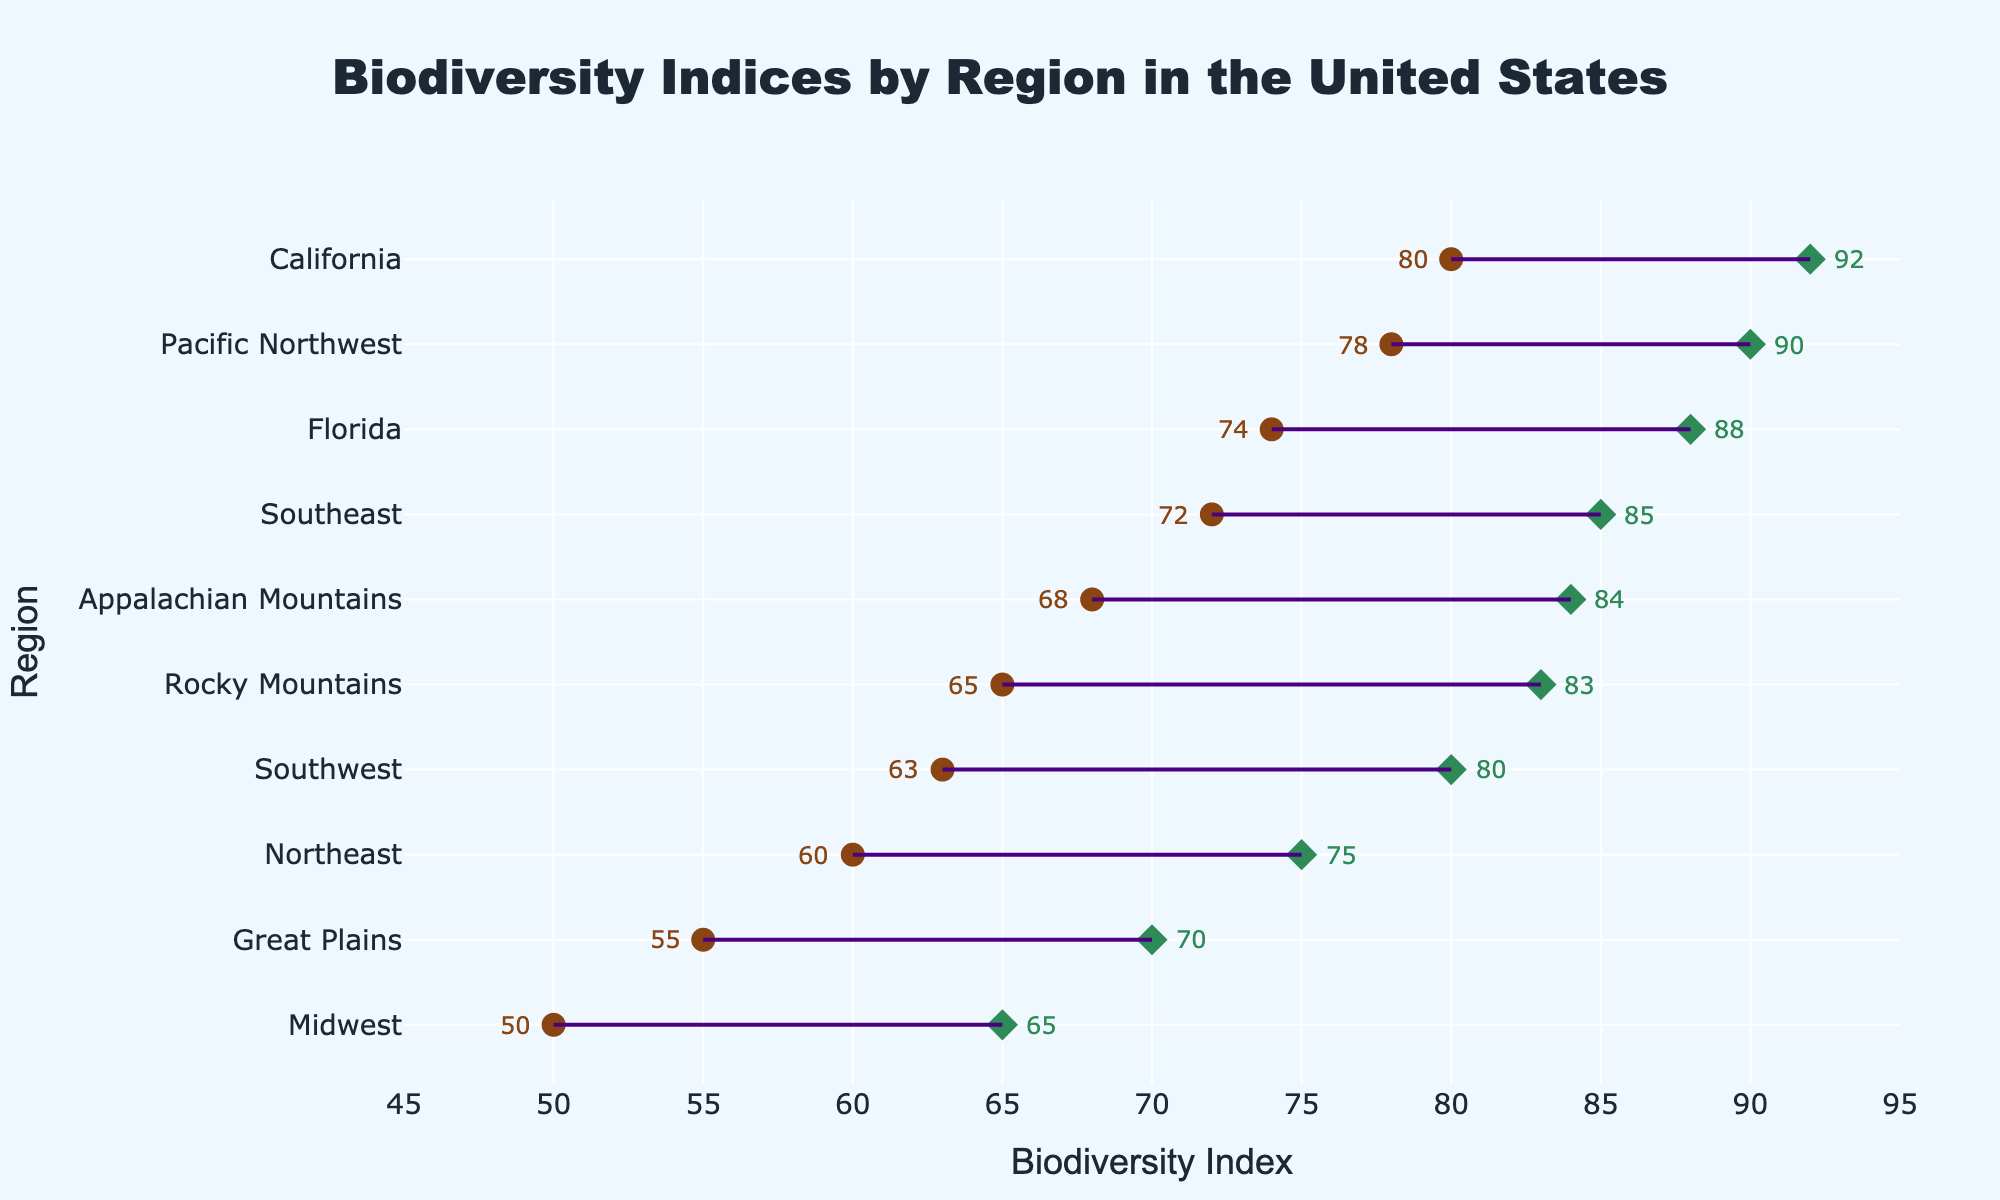Which region has the highest upper biodiversity index? The Pacific Northwest has the highest upper value at 92 according to the rendered plot.
Answer: Pacific Northwest Which regions have a lower biodiversity index of 50 or below? Only the Midwest has a lower biodiversity index of 50, falling within the criteria specified.
Answer: Midwest What's the range of biodiversity indices for the Southeast region? The Southeast region has a lower value of 72 and a higher value of 85. Therefore, the range is 85 - 72 = 13.
Answer: 13 Is the lower biodiversity index of the Midwest greater than the upper biodiversity index of the Great Plains? The lower biodiversity index of the Midwest is 50, and the upper biodiversity index of the Great Plains is 70. Since 50 is not greater than 70, the answer is no.
Answer: No Which two regions have the smallest range of biodiversity indices? The Great Plains and the Northeast both have the smallest range of biodiversity indices at 15 each (70 - 55 and 75 - 60 respectively).
Answer: Great Plains, Northeast What is the median upper biodiversity index across all regions? The upper biodiversity indices in ascending order are 65, 70, 75, 80, 83, 84, 85, 88, 90, 92. The median value is the average of the 5th and 6th index values: (83 + 84) / 2 = 83.5.
Answer: 83.5 Which region has a lower biodiversity index closest to 65? The Rocky Mountains have a lower biodiversity index of 65, which matches the value exactly.
Answer: Rocky Mountains How many regions have an upper biodiversity index of 80 or higher? The regions that meet this criterion are: Pacific Northwest, Southeast, Appalachian Mountains, California, Florida, and Southwest. Therefore, there are 6 regions in total.
Answer: 6 What are the two regions with the highest lower biodiversity indices? The regions with the highest lower biodiversity indices are California (80) and the Pacific Northwest (78).
Answer: California, Pacific Northwest 